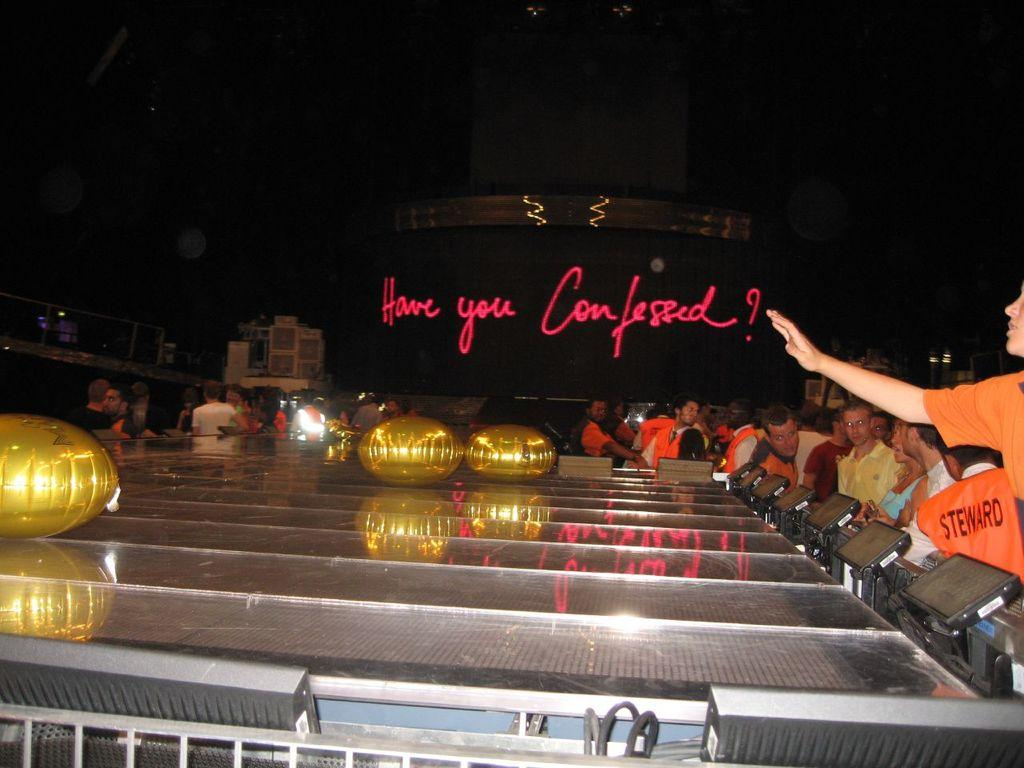Who or what can be seen in the image? There are people in the image. What else is present in the image besides people? There are balloons, devices, and objects in the image. Can you describe the background of the image? The background of the image is dark. What is displayed on a screen in the image? There is a screen with text in the image. What type of kitten is being produced in the image? There is no kitten present in the image, and no production of any kind is depicted. What type of voyage is being undertaken by the people in the image? There is no voyage or journey being undertaken by the people in the image; they are simply present in the scene. 